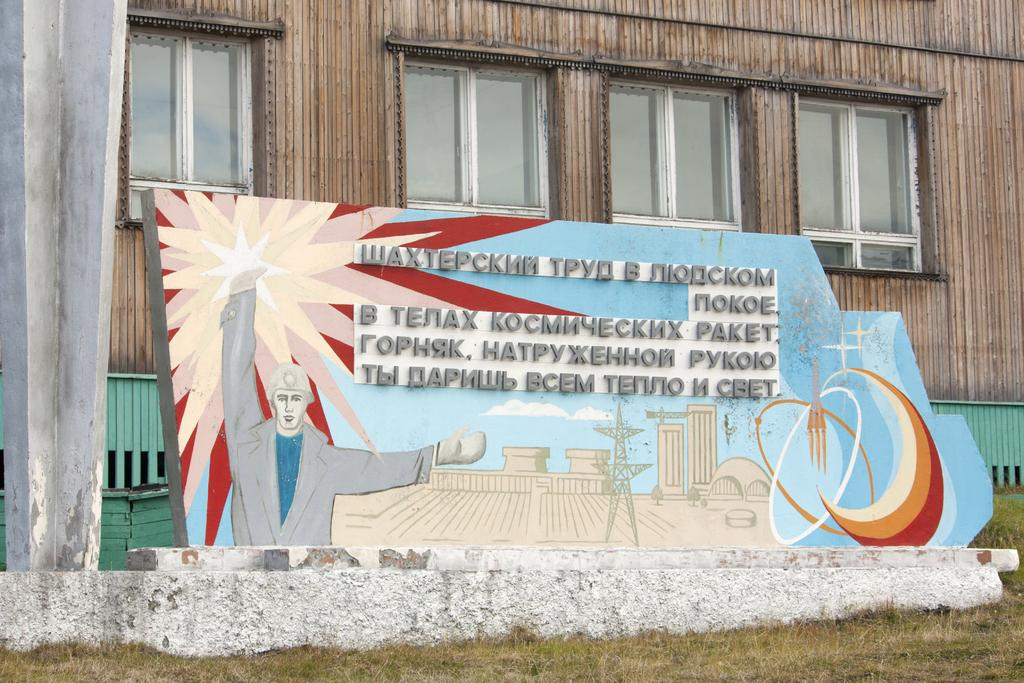What type of vegetation is present in the image? There is grass in the image. What can be seen on the board in the image? There is text on the board in the image. What type of structure is visible in the background of the image? There is a building with windows in the background of the image. How many haircuts are being given in the image? There is no indication of haircuts being given in the image. What attention-grabbing things can be seen in the image? The provided facts do not mention any attention-grabbing things in the image. 